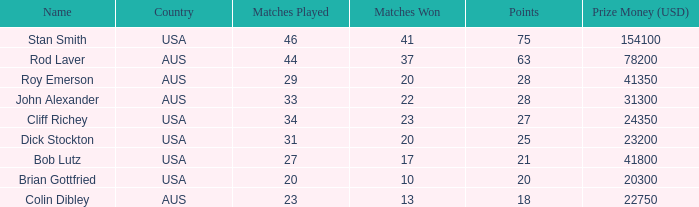What is the number of countries with a score of 21 points? 1.0. 